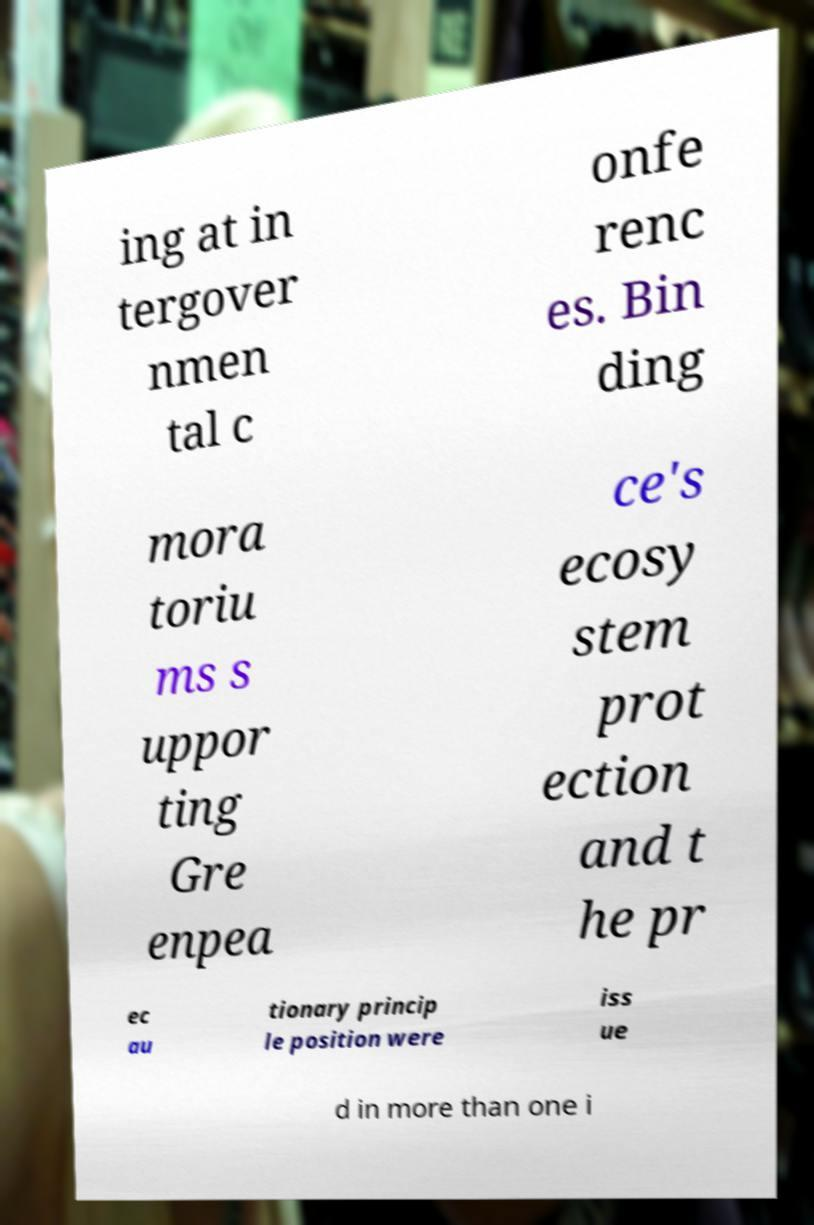Could you extract and type out the text from this image? ing at in tergover nmen tal c onfe renc es. Bin ding mora toriu ms s uppor ting Gre enpea ce's ecosy stem prot ection and t he pr ec au tionary princip le position were iss ue d in more than one i 